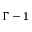<formula> <loc_0><loc_0><loc_500><loc_500>\Gamma - 1</formula> 